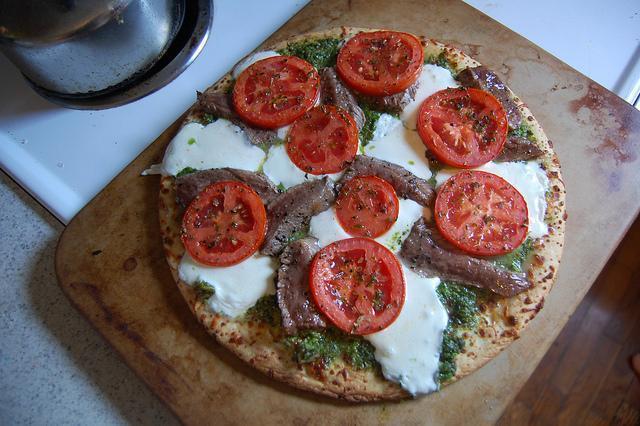Verify the accuracy of this image caption: "The oven contains the pizza.".
Answer yes or no. No. 